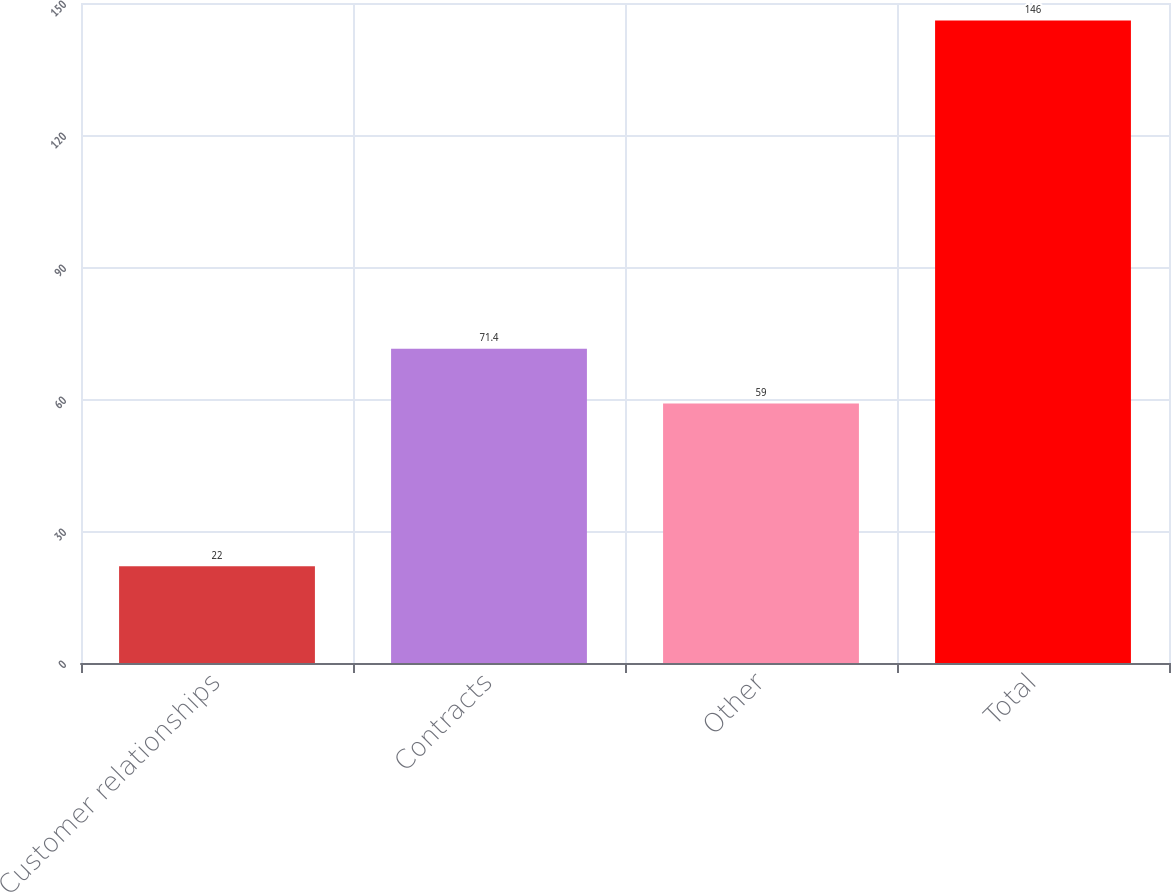Convert chart to OTSL. <chart><loc_0><loc_0><loc_500><loc_500><bar_chart><fcel>Customer relationships<fcel>Contracts<fcel>Other<fcel>Total<nl><fcel>22<fcel>71.4<fcel>59<fcel>146<nl></chart> 